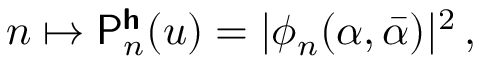Convert formula to latex. <formula><loc_0><loc_0><loc_500><loc_500>n \mapsto P _ { n } ^ { h } ( u ) = | \phi _ { n } ( \alpha , \bar { \alpha } ) | ^ { 2 } \, ,</formula> 